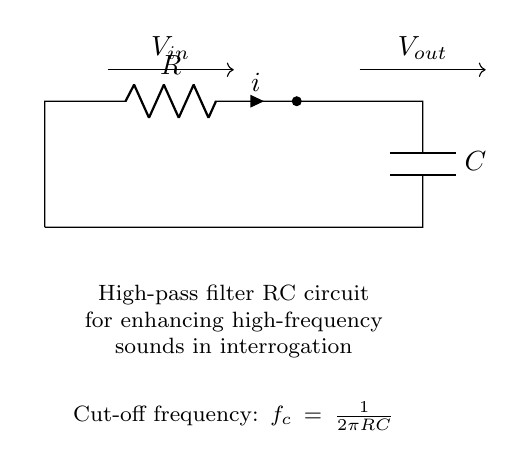What are the components in this circuit? The circuit consists of a resistor and a capacitor arranged in series. These components are labeled in the diagram as R and C.
Answer: resistor, capacitor What is the function of this circuit? This circuit is designed to act as a high-pass filter, which allows high-frequency signals to pass while attenuating lower frequency signals. This is indicated by the label in the diagram.
Answer: high-pass filter What is the formula for cut-off frequency in this circuit? The cut-off frequency is represented by the formula shown in the diagram: f_c = 1/(2πRC). This formula describes how the cut-off frequency depends on the values of R and C.
Answer: f_c = 1/(2πRC) What does the output voltage represent? The output voltage represents the voltage across the capacitor, which is the filtered signal after high-frequency sounds have been enhanced, as shown by the output label in the diagram.
Answer: filtered signal What happens to low-frequency signals in this circuit? Low-frequency signals are attenuated or reduced, meaning they do not effectively pass through the circuit. This behavior is characteristic of high-pass filters.
Answer: attenuated Which component controls the time constant of the circuit? The time constant is influenced by both the resistor (R) and capacitor (C) since it is the product of these two components (RC). Therefore, both components together determine how quickly the circuit can respond to changes in frequency.
Answer: R and C 